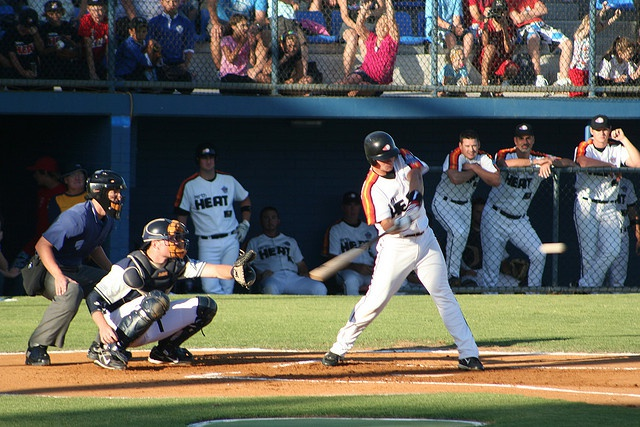Describe the objects in this image and their specific colors. I can see people in black, gray, navy, and maroon tones, people in black, ivory, and gray tones, people in black, white, and darkgray tones, people in black, gray, and darkgray tones, and people in black and gray tones in this image. 